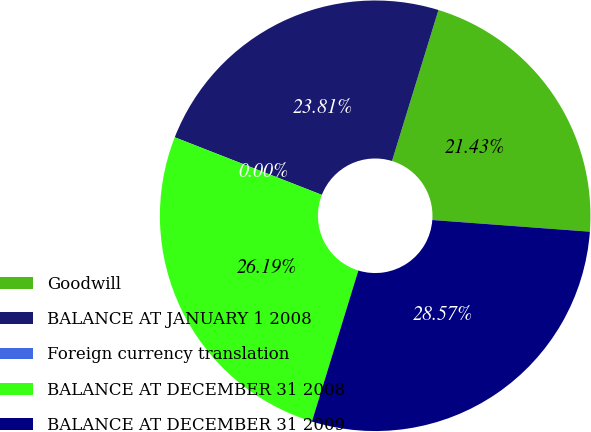<chart> <loc_0><loc_0><loc_500><loc_500><pie_chart><fcel>Goodwill<fcel>BALANCE AT JANUARY 1 2008<fcel>Foreign currency translation<fcel>BALANCE AT DECEMBER 31 2008<fcel>BALANCE AT DECEMBER 31 2009<nl><fcel>21.43%<fcel>23.81%<fcel>0.0%<fcel>26.19%<fcel>28.57%<nl></chart> 